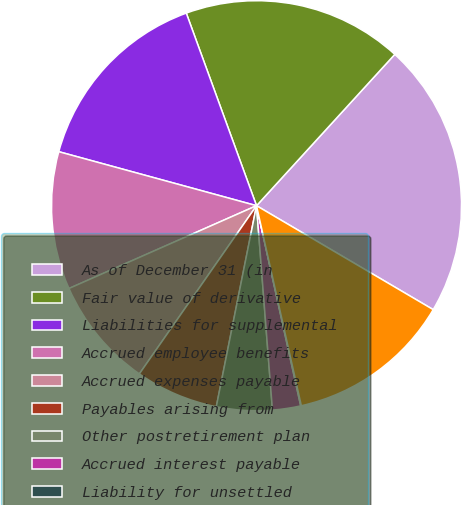<chart> <loc_0><loc_0><loc_500><loc_500><pie_chart><fcel>As of December 31 (in<fcel>Fair value of derivative<fcel>Liabilities for supplemental<fcel>Accrued employee benefits<fcel>Accrued expenses payable<fcel>Payables arising from<fcel>Other postretirement plan<fcel>Accrued interest payable<fcel>Liability for unsettled<fcel>Other (1)<nl><fcel>21.68%<fcel>17.35%<fcel>15.19%<fcel>10.86%<fcel>8.7%<fcel>6.54%<fcel>4.38%<fcel>2.22%<fcel>0.05%<fcel>13.03%<nl></chart> 